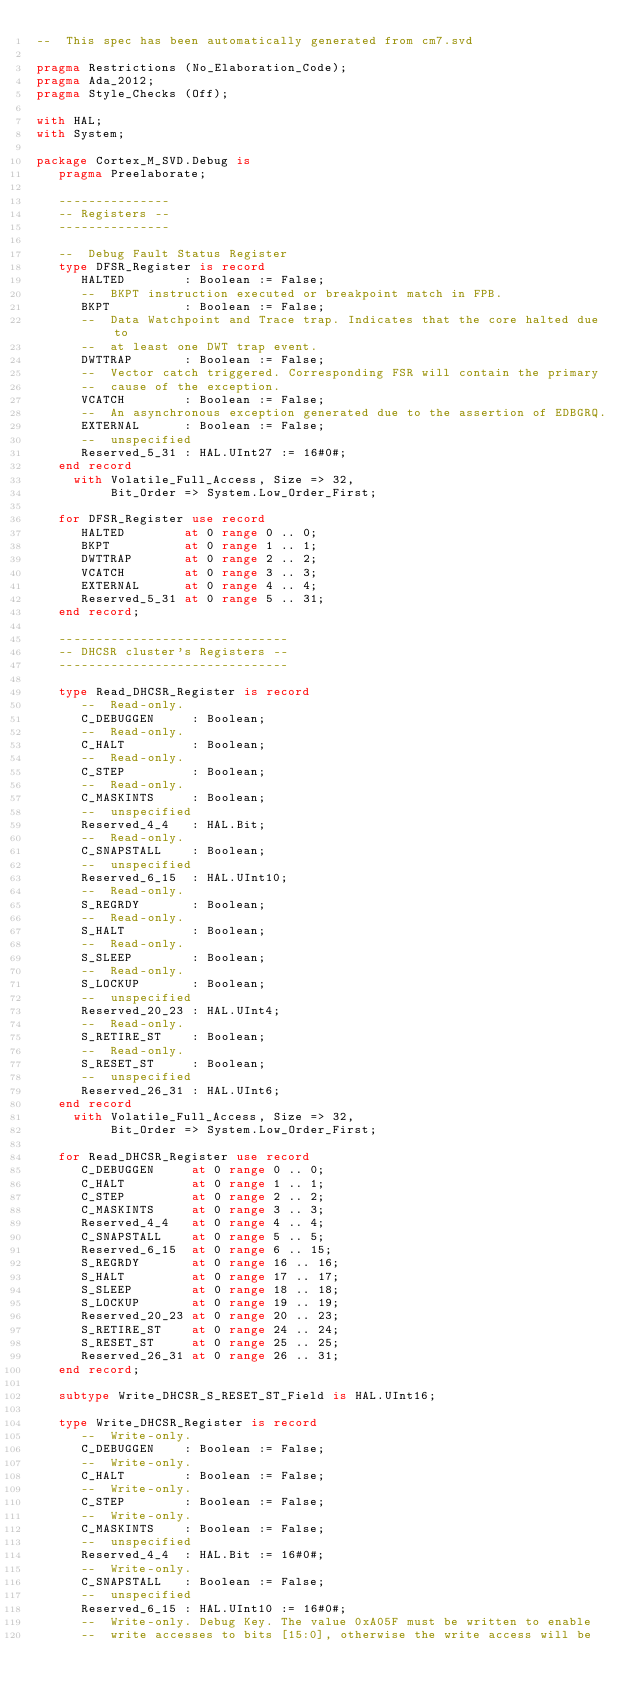<code> <loc_0><loc_0><loc_500><loc_500><_Ada_>--  This spec has been automatically generated from cm7.svd

pragma Restrictions (No_Elaboration_Code);
pragma Ada_2012;
pragma Style_Checks (Off);

with HAL;
with System;

package Cortex_M_SVD.Debug is
   pragma Preelaborate;

   ---------------
   -- Registers --
   ---------------

   --  Debug Fault Status Register
   type DFSR_Register is record
      HALTED        : Boolean := False;
      --  BKPT instruction executed or breakpoint match in FPB.
      BKPT          : Boolean := False;
      --  Data Watchpoint and Trace trap. Indicates that the core halted due to
      --  at least one DWT trap event.
      DWTTRAP       : Boolean := False;
      --  Vector catch triggered. Corresponding FSR will contain the primary
      --  cause of the exception.
      VCATCH        : Boolean := False;
      --  An asynchronous exception generated due to the assertion of EDBGRQ.
      EXTERNAL      : Boolean := False;
      --  unspecified
      Reserved_5_31 : HAL.UInt27 := 16#0#;
   end record
     with Volatile_Full_Access, Size => 32,
          Bit_Order => System.Low_Order_First;

   for DFSR_Register use record
      HALTED        at 0 range 0 .. 0;
      BKPT          at 0 range 1 .. 1;
      DWTTRAP       at 0 range 2 .. 2;
      VCATCH        at 0 range 3 .. 3;
      EXTERNAL      at 0 range 4 .. 4;
      Reserved_5_31 at 0 range 5 .. 31;
   end record;

   -------------------------------
   -- DHCSR cluster's Registers --
   -------------------------------

   type Read_DHCSR_Register is record
      --  Read-only.
      C_DEBUGGEN     : Boolean;
      --  Read-only.
      C_HALT         : Boolean;
      --  Read-only.
      C_STEP         : Boolean;
      --  Read-only.
      C_MASKINTS     : Boolean;
      --  unspecified
      Reserved_4_4   : HAL.Bit;
      --  Read-only.
      C_SNAPSTALL    : Boolean;
      --  unspecified
      Reserved_6_15  : HAL.UInt10;
      --  Read-only.
      S_REGRDY       : Boolean;
      --  Read-only.
      S_HALT         : Boolean;
      --  Read-only.
      S_SLEEP        : Boolean;
      --  Read-only.
      S_LOCKUP       : Boolean;
      --  unspecified
      Reserved_20_23 : HAL.UInt4;
      --  Read-only.
      S_RETIRE_ST    : Boolean;
      --  Read-only.
      S_RESET_ST     : Boolean;
      --  unspecified
      Reserved_26_31 : HAL.UInt6;
   end record
     with Volatile_Full_Access, Size => 32,
          Bit_Order => System.Low_Order_First;

   for Read_DHCSR_Register use record
      C_DEBUGGEN     at 0 range 0 .. 0;
      C_HALT         at 0 range 1 .. 1;
      C_STEP         at 0 range 2 .. 2;
      C_MASKINTS     at 0 range 3 .. 3;
      Reserved_4_4   at 0 range 4 .. 4;
      C_SNAPSTALL    at 0 range 5 .. 5;
      Reserved_6_15  at 0 range 6 .. 15;
      S_REGRDY       at 0 range 16 .. 16;
      S_HALT         at 0 range 17 .. 17;
      S_SLEEP        at 0 range 18 .. 18;
      S_LOCKUP       at 0 range 19 .. 19;
      Reserved_20_23 at 0 range 20 .. 23;
      S_RETIRE_ST    at 0 range 24 .. 24;
      S_RESET_ST     at 0 range 25 .. 25;
      Reserved_26_31 at 0 range 26 .. 31;
   end record;

   subtype Write_DHCSR_S_RESET_ST_Field is HAL.UInt16;

   type Write_DHCSR_Register is record
      --  Write-only.
      C_DEBUGGEN    : Boolean := False;
      --  Write-only.
      C_HALT        : Boolean := False;
      --  Write-only.
      C_STEP        : Boolean := False;
      --  Write-only.
      C_MASKINTS    : Boolean := False;
      --  unspecified
      Reserved_4_4  : HAL.Bit := 16#0#;
      --  Write-only.
      C_SNAPSTALL   : Boolean := False;
      --  unspecified
      Reserved_6_15 : HAL.UInt10 := 16#0#;
      --  Write-only. Debug Key. The value 0xA05F must be written to enable
      --  write accesses to bits [15:0], otherwise the write access will be</code> 